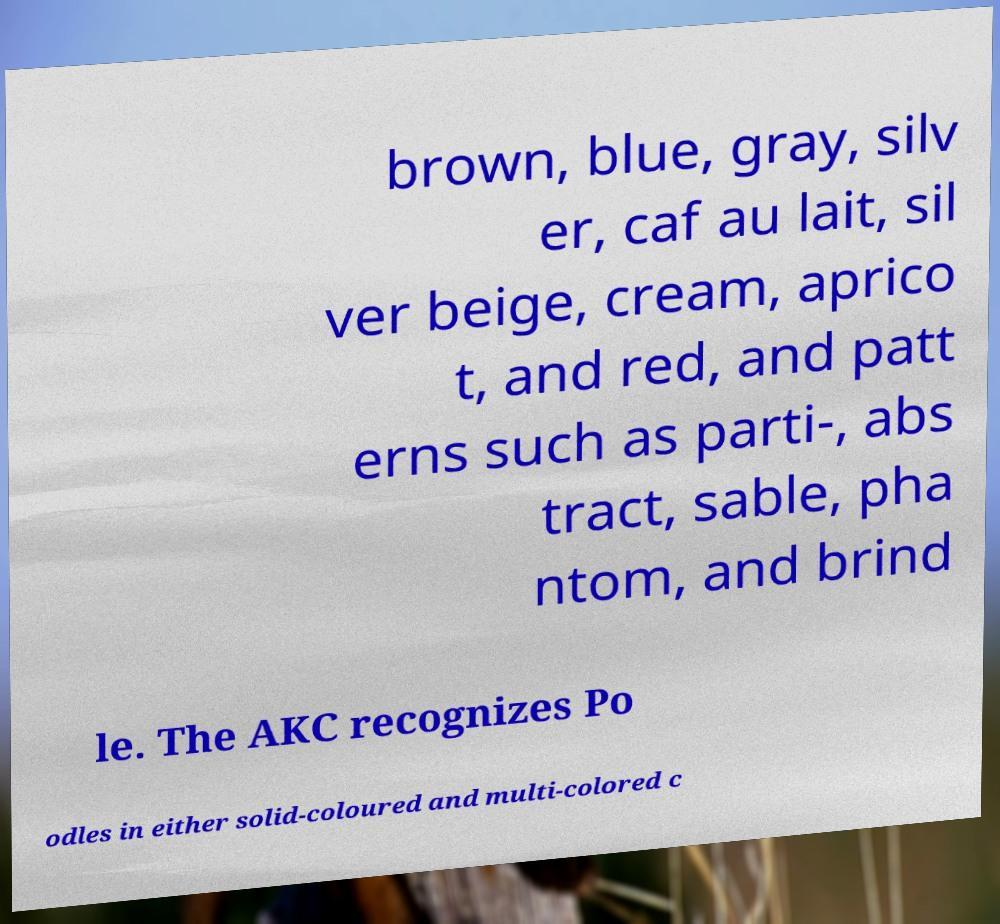For documentation purposes, I need the text within this image transcribed. Could you provide that? brown, blue, gray, silv er, caf au lait, sil ver beige, cream, aprico t, and red, and patt erns such as parti-, abs tract, sable, pha ntom, and brind le. The AKC recognizes Po odles in either solid-coloured and multi-colored c 